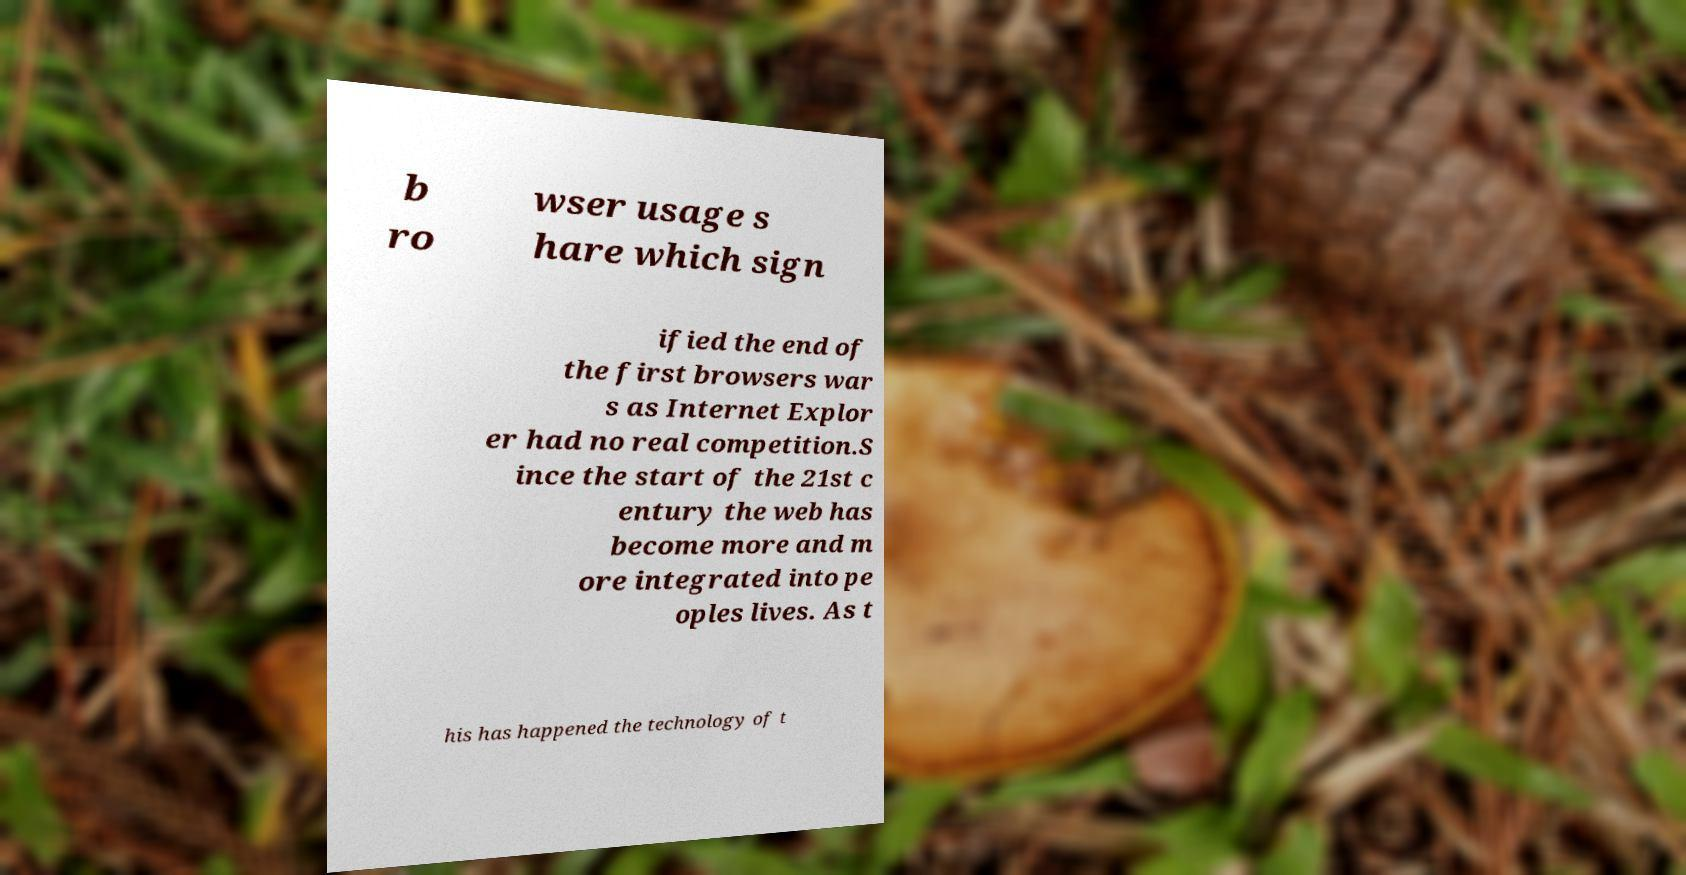For documentation purposes, I need the text within this image transcribed. Could you provide that? b ro wser usage s hare which sign ified the end of the first browsers war s as Internet Explor er had no real competition.S ince the start of the 21st c entury the web has become more and m ore integrated into pe oples lives. As t his has happened the technology of t 